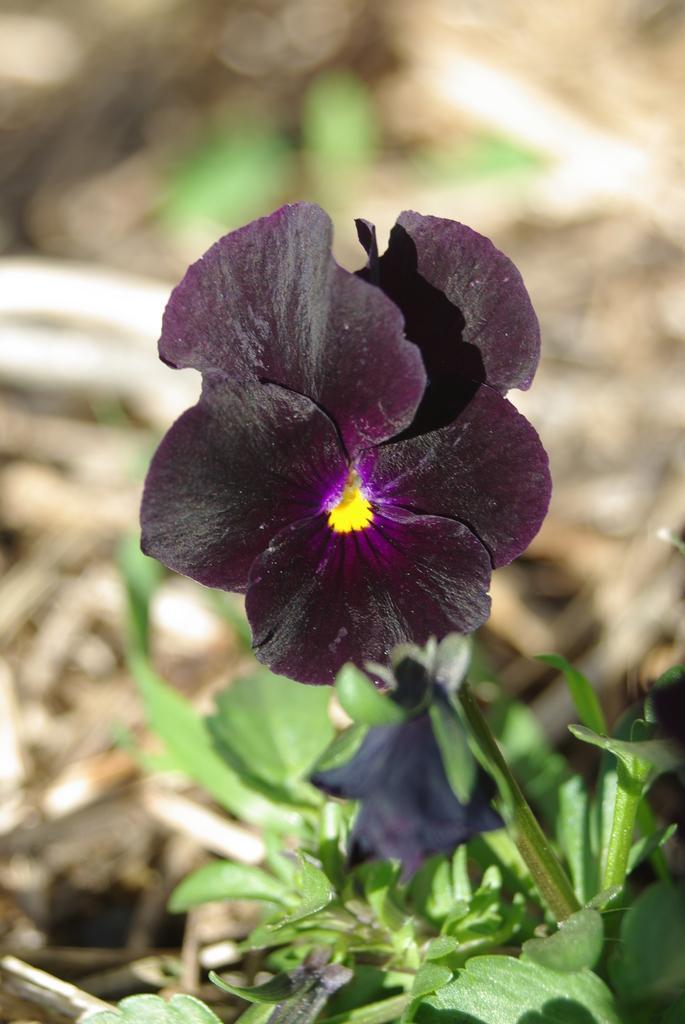Please provide a concise description of this image. In this picture we can see a plant with a flower. Behind the flower there is the blurred background. 